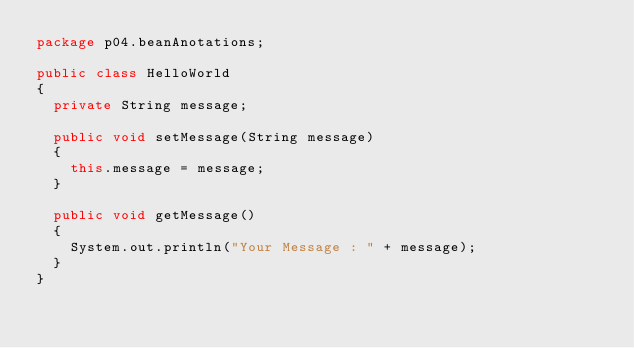Convert code to text. <code><loc_0><loc_0><loc_500><loc_500><_Java_>package p04.beanAnotations;

public class HelloWorld
{
  private String message;
  
  public void setMessage(String message)
  {
    this.message = message;
  }
  
  public void getMessage()
  {
    System.out.println("Your Message : " + message);
  }
}</code> 